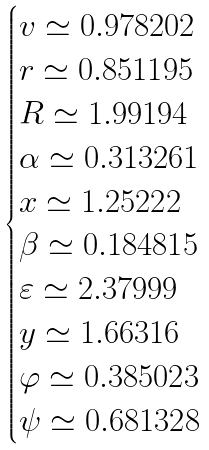<formula> <loc_0><loc_0><loc_500><loc_500>\begin{cases} v \simeq 0 . 9 7 8 2 0 2 \\ r \simeq 0 . 8 5 1 1 9 5 \\ R \simeq 1 . 9 9 1 9 4 \\ \alpha \simeq 0 . 3 1 3 2 6 1 \\ x \simeq 1 . 2 5 2 2 2 \\ \beta \simeq 0 . 1 8 4 8 1 5 \\ \varepsilon \simeq 2 . 3 7 9 9 9 \\ y \simeq 1 . 6 6 3 1 6 \\ \varphi \simeq 0 . 3 8 5 0 2 3 \\ \psi \simeq 0 . 6 8 1 3 2 8 \end{cases}</formula> 